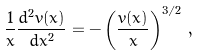<formula> <loc_0><loc_0><loc_500><loc_500>\frac { 1 } { x } \frac { d ^ { 2 } v ( x ) } { d x ^ { 2 } } = - \left ( \frac { v ( x ) } { x } \right ) ^ { 3 / 2 } \, ,</formula> 